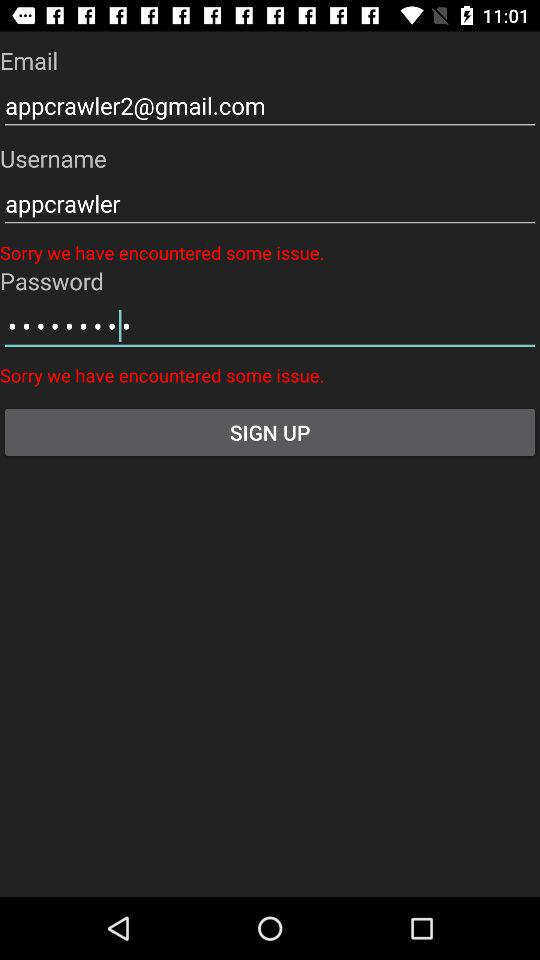What is the email address? The email address is appcrawler2@gmail.com. 